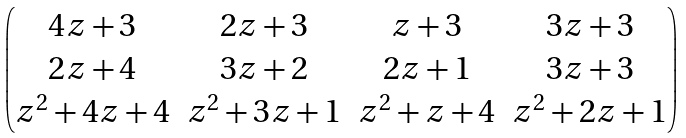Convert formula to latex. <formula><loc_0><loc_0><loc_500><loc_500>\begin{pmatrix} 4 z + 3 & 2 z + 3 & z + 3 & 3 z + 3 \\ 2 z + 4 & 3 z + 2 & 2 z + 1 & 3 z + 3 \\ z ^ { 2 } + 4 z + 4 & z ^ { 2 } + 3 z + 1 & z ^ { 2 } + z + 4 & z ^ { 2 } + 2 z + 1 \end{pmatrix}</formula> 